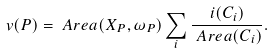<formula> <loc_0><loc_0><loc_500><loc_500>v ( P ) & = \ A r e a ( X _ { P } , \omega _ { P } ) \sum _ { i } \frac { i ( C _ { i } ) } { \ A r e a ( C _ { i } ) } .</formula> 